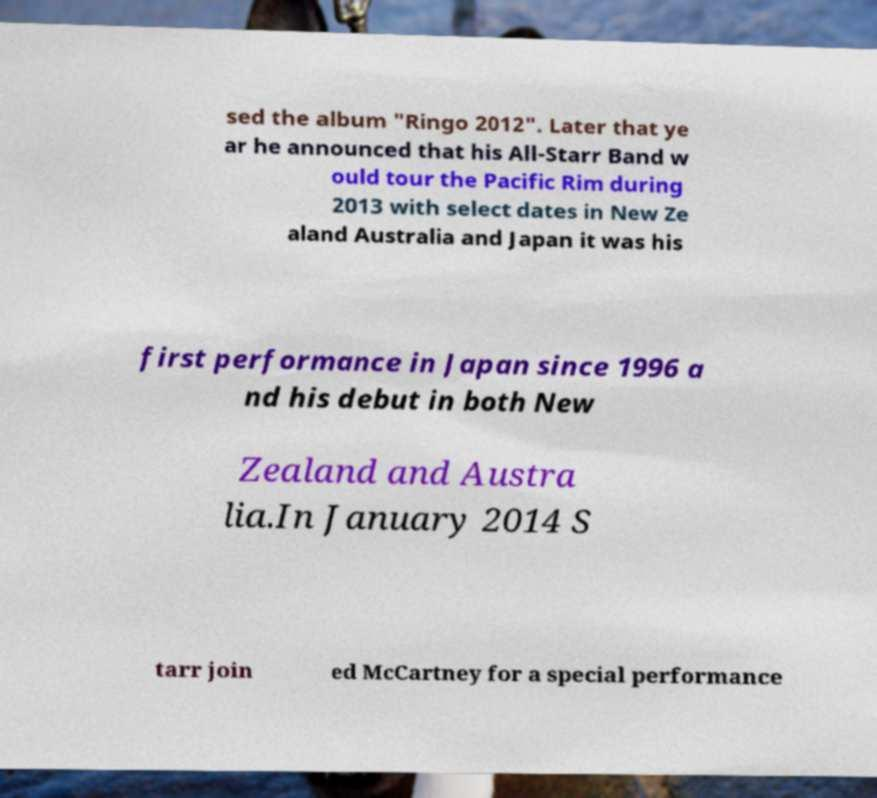For documentation purposes, I need the text within this image transcribed. Could you provide that? sed the album "Ringo 2012". Later that ye ar he announced that his All-Starr Band w ould tour the Pacific Rim during 2013 with select dates in New Ze aland Australia and Japan it was his first performance in Japan since 1996 a nd his debut in both New Zealand and Austra lia.In January 2014 S tarr join ed McCartney for a special performance 